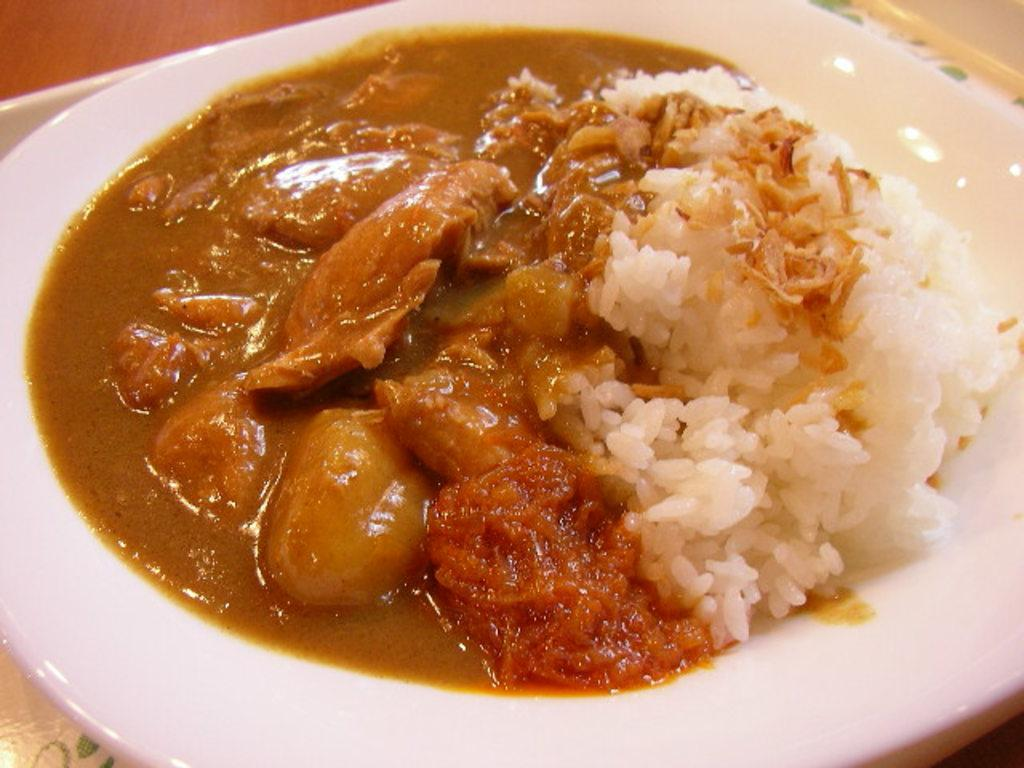What is on the plate that is visible in the image? There is a food item on a plate in the image. Can you describe the object on which the plate is placed? The plate is on an object in the image, but the specific object is not mentioned in the provided facts. What type of flag is being waved in the image? There is no flag present in the image. What time of day is represented by the hour in the image? There is no hour present in the image. What type of agreement is being signed in the image? There is no agreement or signing activity present in the image. 